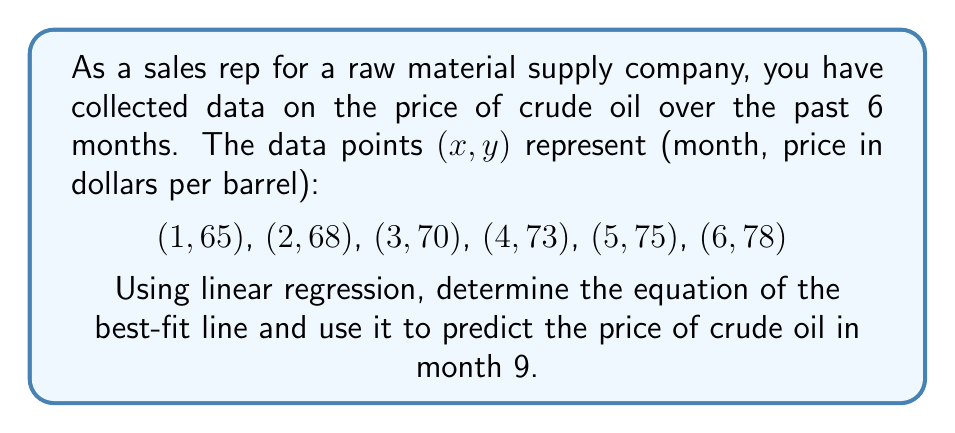Help me with this question. 1. To find the linear regression equation, we need to calculate the slope (m) and y-intercept (b) of the best-fit line.

2. Calculate the means of x and y:
   $\bar{x} = \frac{1+2+3+4+5+6}{6} = 3.5$
   $\bar{y} = \frac{65+68+70+73+75+78}{6} = 71.5$

3. Calculate the slope (m) using the formula:
   $$m = \frac{\sum(x_i - \bar{x})(y_i - \bar{y})}{\sum(x_i - \bar{x})^2}$$

4. Calculate the numerator and denominator:
   Numerator: $(-2.5)(-6.5) + (-1.5)(-3.5) + (-0.5)(-1.5) + (0.5)(1.5) + (1.5)(3.5) + (2.5)(6.5) = 52.5$
   Denominator: $(-2.5)^2 + (-1.5)^2 + (-0.5)^2 + (0.5)^2 + (1.5)^2 + (2.5)^2 = 17.5$

5. Calculate the slope:
   $m = \frac{52.5}{17.5} = 3$

6. Calculate the y-intercept (b) using the formula:
   $b = \bar{y} - m\bar{x} = 71.5 - 3(3.5) = 61$

7. The linear regression equation is:
   $y = 3x + 61$

8. To predict the price in month 9, substitute x = 9 into the equation:
   $y = 3(9) + 61 = 88$
Answer: $88 per barrel 